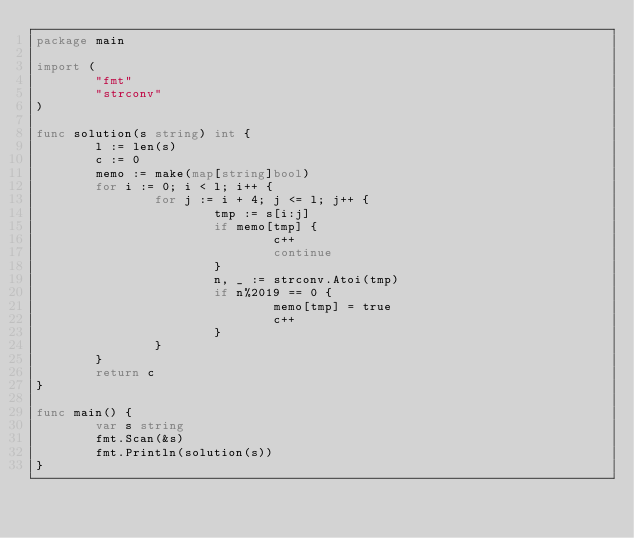Convert code to text. <code><loc_0><loc_0><loc_500><loc_500><_Go_>package main

import (
        "fmt"
        "strconv"
)

func solution(s string) int {
        l := len(s)
        c := 0
        memo := make(map[string]bool)
        for i := 0; i < l; i++ {
                for j := i + 4; j <= l; j++ {
                        tmp := s[i:j]
                        if memo[tmp] {
                                c++
                                continue
                        }
                        n, _ := strconv.Atoi(tmp)
                        if n%2019 == 0 {
                                memo[tmp] = true
                                c++
                        }
                }
        }
        return c
}

func main() {
        var s string
        fmt.Scan(&s)
        fmt.Println(solution(s))
}</code> 